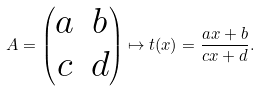Convert formula to latex. <formula><loc_0><loc_0><loc_500><loc_500>A = \begin{pmatrix} a & b \\ c & d \end{pmatrix} \mapsto t ( x ) = \frac { a x + b } { c x + d } .</formula> 